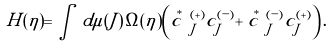Convert formula to latex. <formula><loc_0><loc_0><loc_500><loc_500>H ( \eta ) = \int \, d \mu ( J ) \, \Omega ( \eta ) \left ( \stackrel { \, * } { c } { \, } ^ { ( + ) } _ { J } c ^ { ( - ) } _ { J } + \stackrel { \, * } { c } { \, } ^ { ( - ) } _ { J } c ^ { ( + ) } _ { J } \right ) .</formula> 